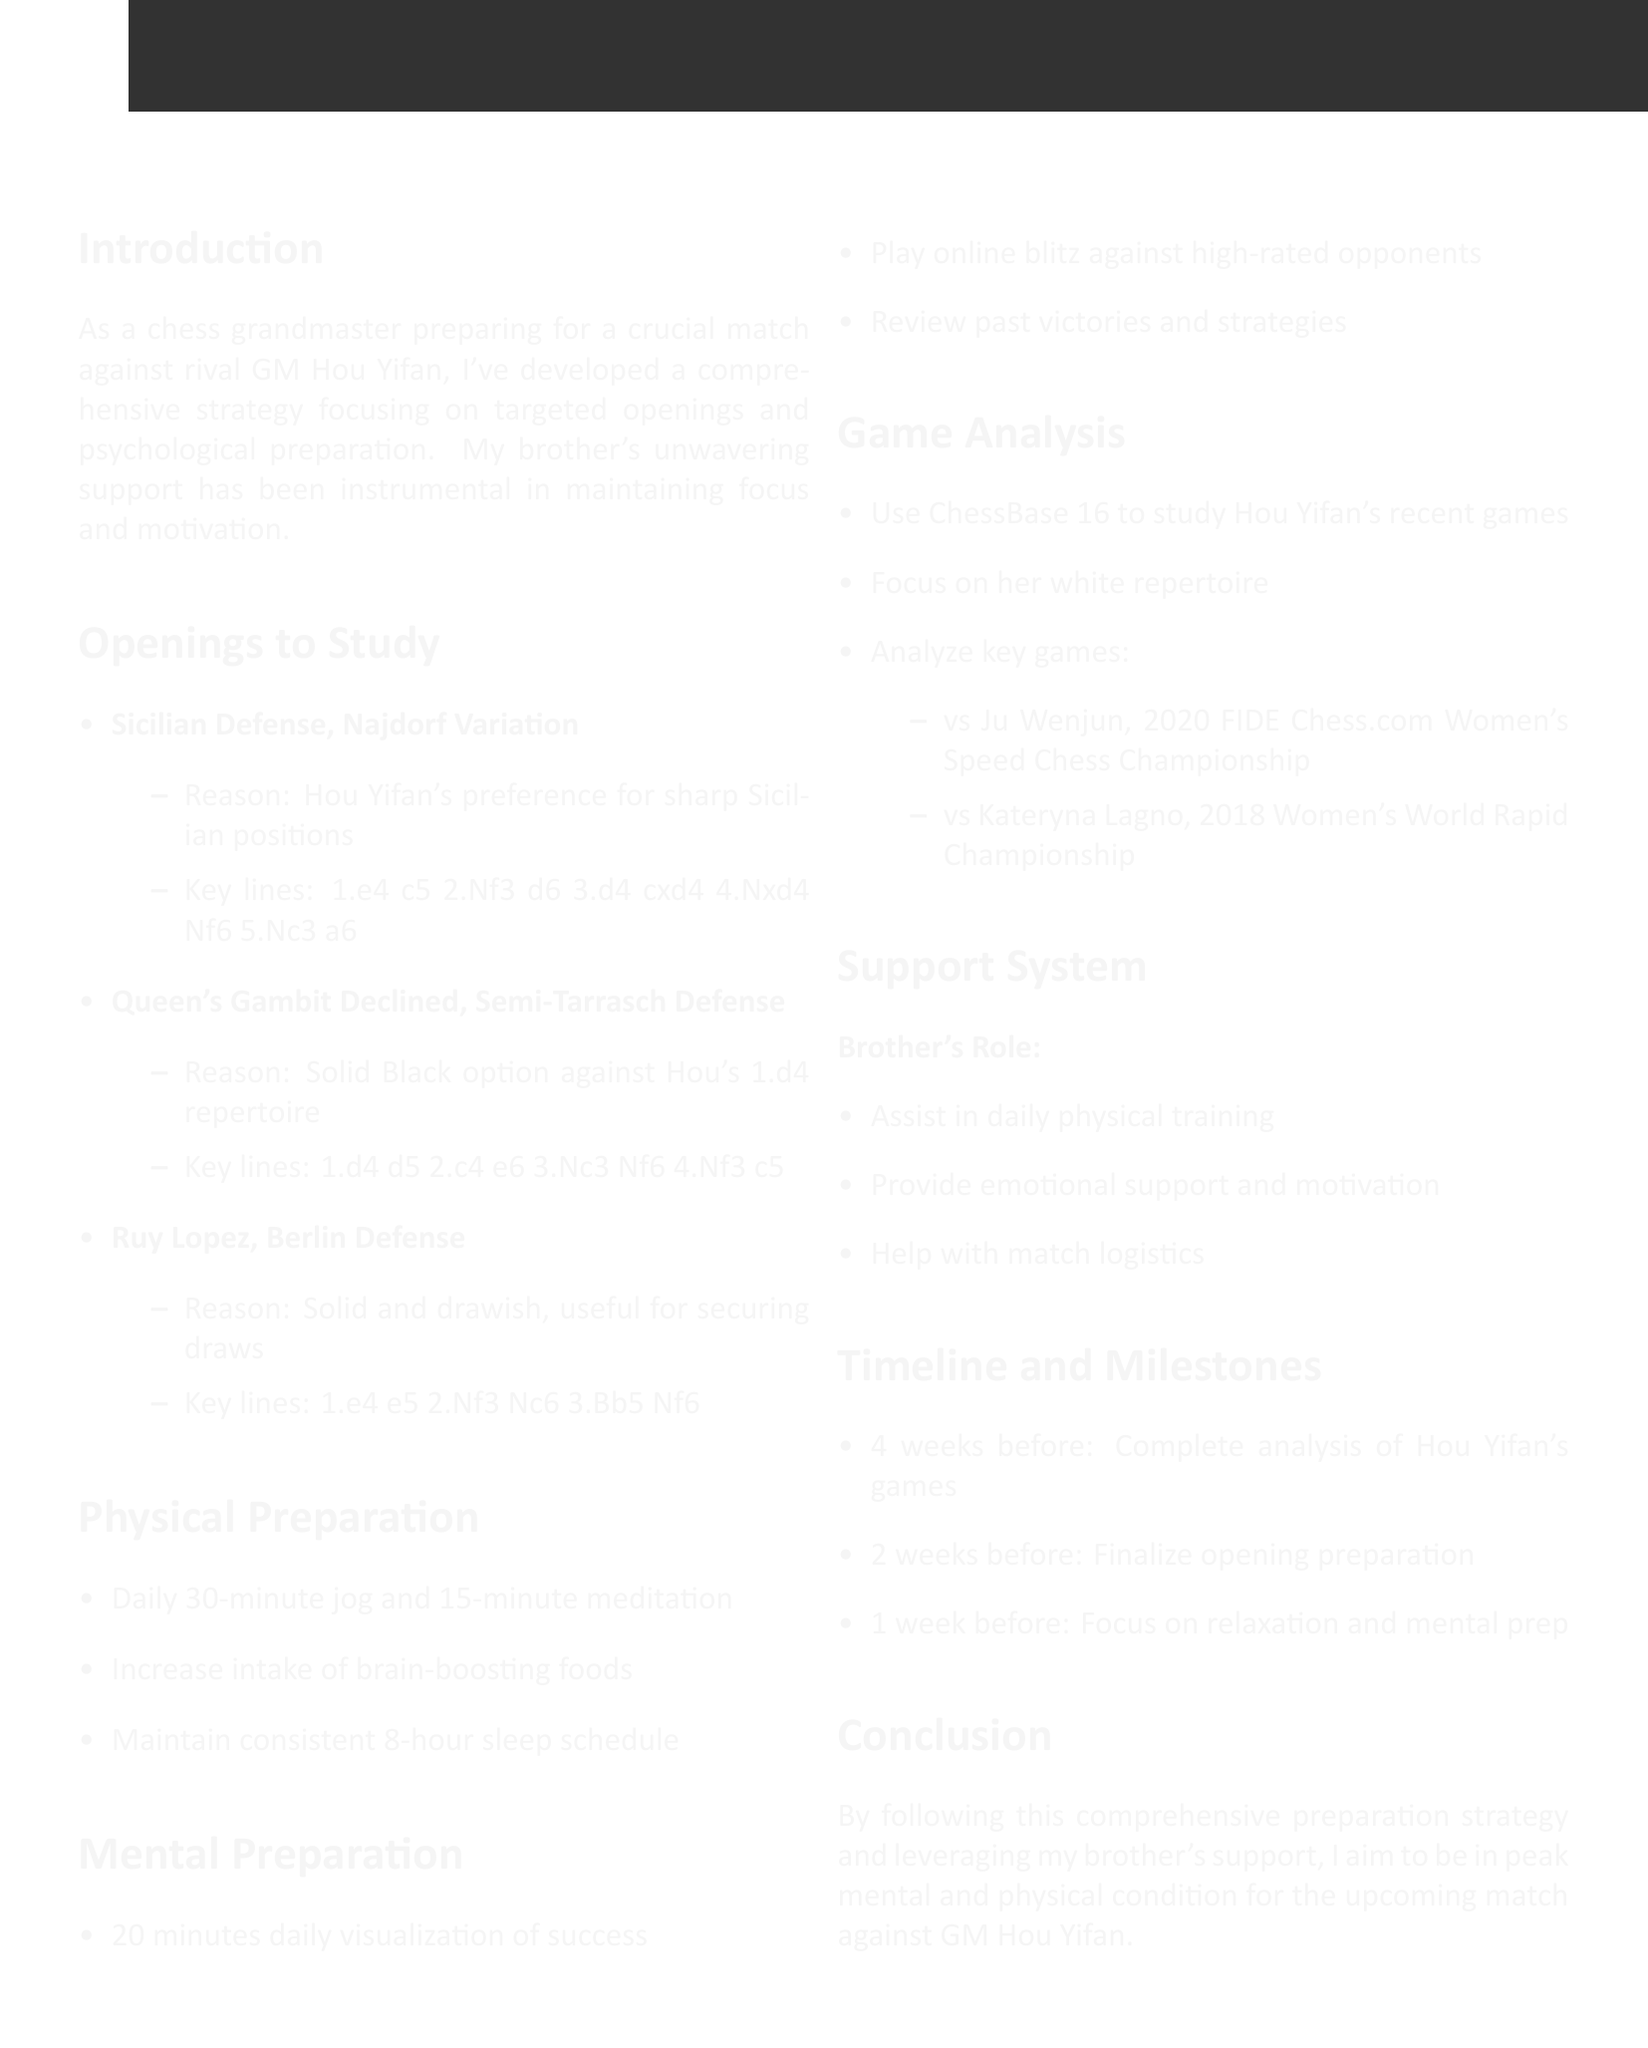what is the title of the memo? The title of the memo is explicitly stated at the beginning of the document.
Answer: Preparation Strategy for Match Against GM Hou Yifan who is the rival grandmaster mentioned in the memo? The rival grandmaster is mentioned in the introduction section of the document.
Answer: GM Hou Yifan how many openings are listed to study? The number of openings can be counted in the "Openings to Study" section of the document.
Answer: 3 what exercise is recommended for physical preparation? The exercise is mentioned in the "Physical Preparation" section of the document.
Answer: Daily 30-minute jog what is the main tool for game analysis? The tool used for game analysis is specified in the "Game Analysis" section of the memo.
Answer: ChessBase 16 how many weeks before the match should the analysis of Hou Yifan's games be completed? The timeline for analysis completion is clearly stated in the "Timeline and Milestones" section.
Answer: 4 weeks what type of visualization is suggested for mental preparation? The type of visualization is described under the "Mental Preparation" section.
Answer: Successful game scenarios what role does the brother play in the support system? The role of the brother is outlined in the "Support System" section of the document.
Answer: Provide emotional support and motivation what key game is highlighted for analysis against Hou Yifan? One of the key games for analysis is mentioned in the "Game Analysis" section.
Answer: Hou Yifan vs Ju Wenjun, 2020 FIDE Chess.com Women's Speed Chess Championship 